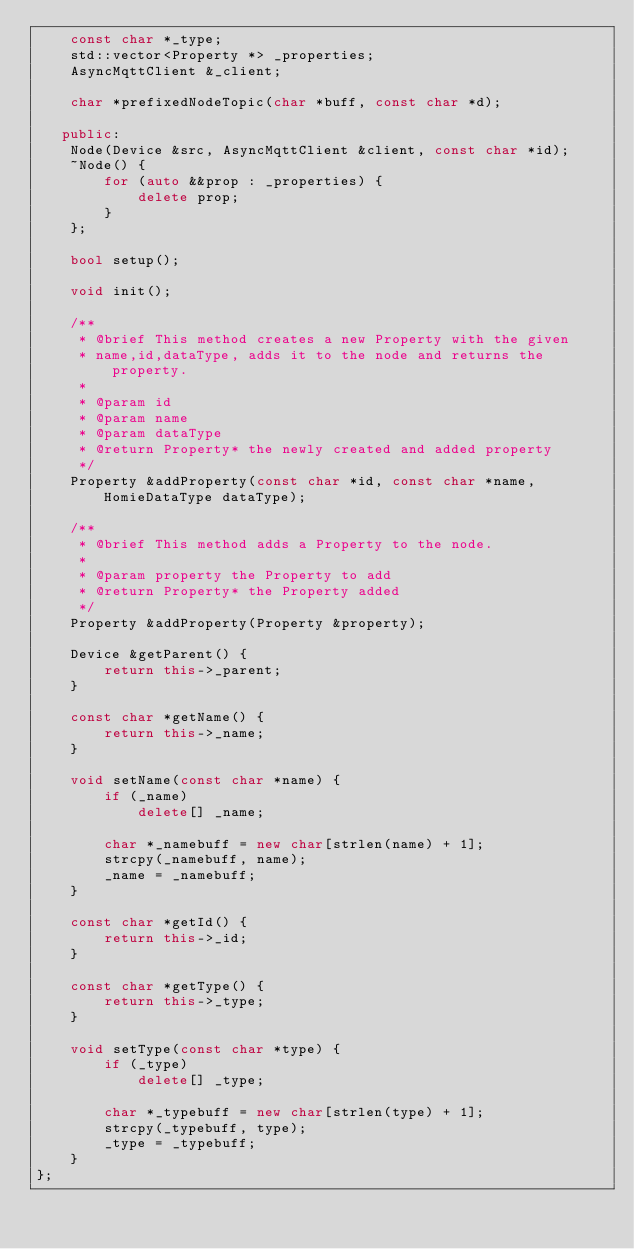<code> <loc_0><loc_0><loc_500><loc_500><_C++_>    const char *_type;
    std::vector<Property *> _properties;
    AsyncMqttClient &_client;

    char *prefixedNodeTopic(char *buff, const char *d);

   public:
    Node(Device &src, AsyncMqttClient &client, const char *id);
    ~Node() {
        for (auto &&prop : _properties) {
            delete prop;
        }
    };

    bool setup();

    void init();

    /**
     * @brief This method creates a new Property with the given 
     * name,id,dataType, adds it to the node and returns the property.
     * 
     * @param id 
     * @param name 
     * @param dataType 
     * @return Property* the newly created and added property
     */
    Property &addProperty(const char *id, const char *name, HomieDataType dataType);

    /**
     * @brief This method adds a Property to the node.
     * 
     * @param property the Property to add
     * @return Property* the Property added
     */
    Property &addProperty(Property &property);

    Device &getParent() {
        return this->_parent;
    }

    const char *getName() {
        return this->_name;
    }

    void setName(const char *name) {
        if (_name)
            delete[] _name;

        char *_namebuff = new char[strlen(name) + 1];
        strcpy(_namebuff, name);
        _name = _namebuff;
    }

    const char *getId() {
        return this->_id;
    }

    const char *getType() {
        return this->_type;
    }

    void setType(const char *type) {
        if (_type)
            delete[] _type;

        char *_typebuff = new char[strlen(type) + 1];
        strcpy(_typebuff, type);
        _type = _typebuff;
    }
};
</code> 